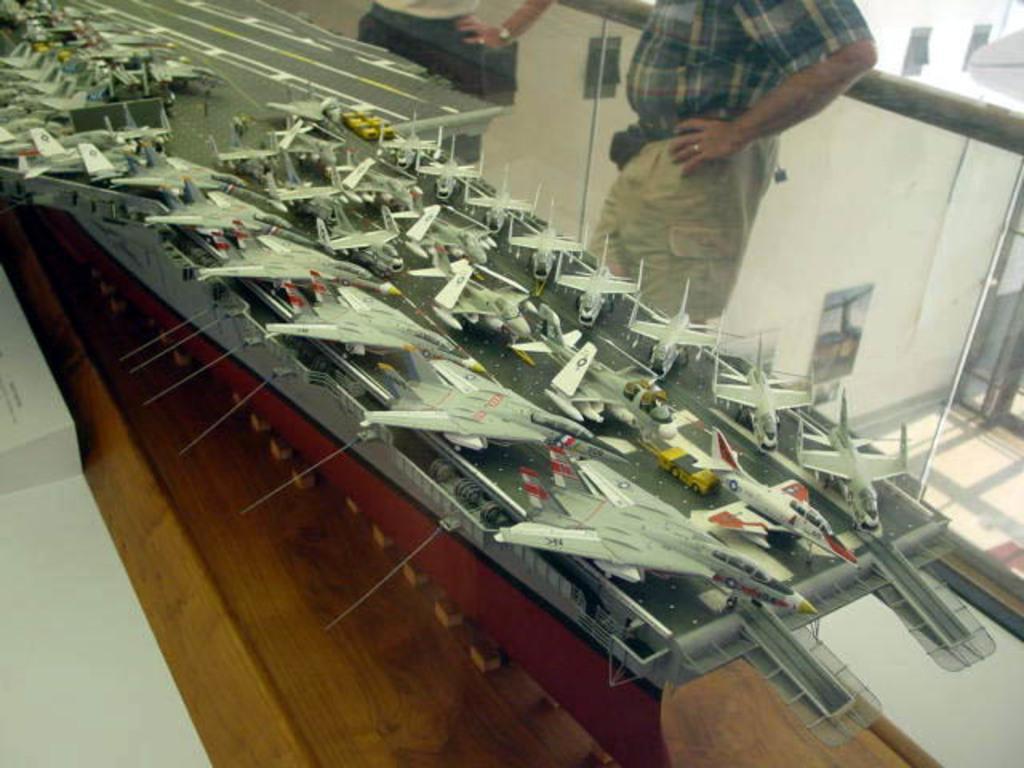In one or two sentences, can you explain what this image depicts? In this image we can see demo of some air crafts which are moving on the runway and in the background of the image there are two persons standing near the glass fencing through which we can see a building. 